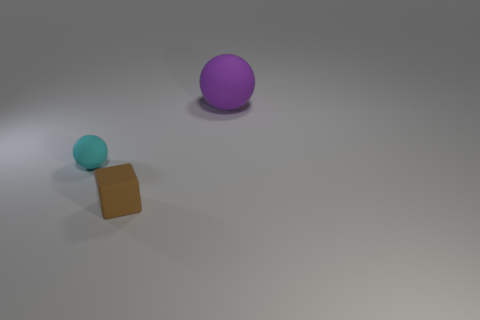Add 3 big purple matte objects. How many objects exist? 6 Subtract all blocks. How many objects are left? 2 Add 2 cyan rubber things. How many cyan rubber things exist? 3 Subtract 0 green balls. How many objects are left? 3 Subtract all green spheres. Subtract all yellow cylinders. How many spheres are left? 2 Subtract all big purple things. Subtract all cyan things. How many objects are left? 1 Add 1 tiny objects. How many tiny objects are left? 3 